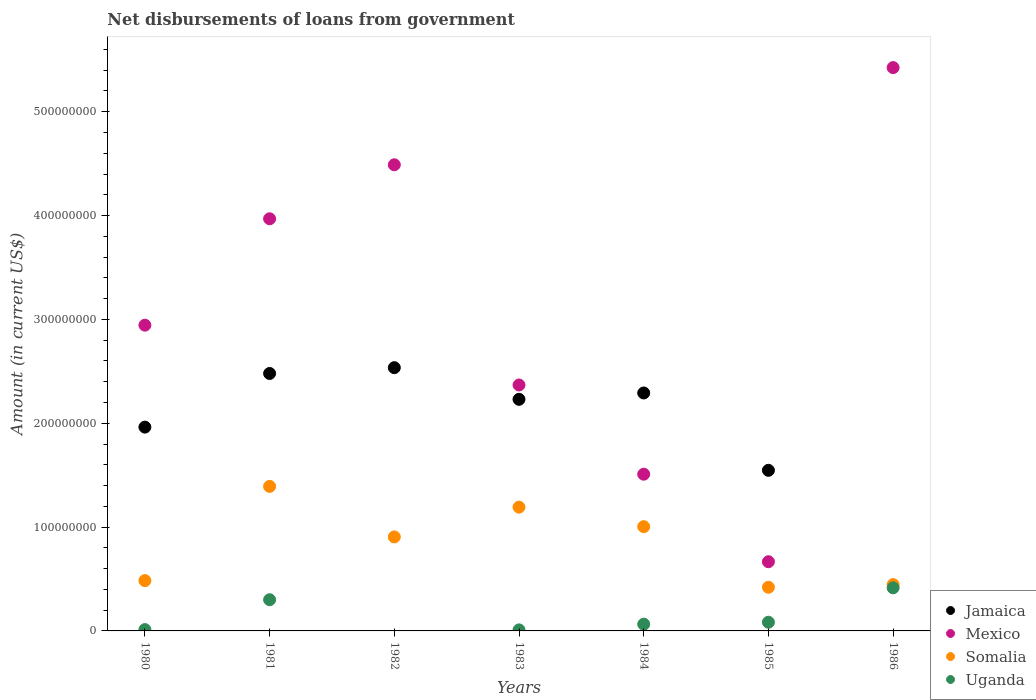Is the number of dotlines equal to the number of legend labels?
Give a very brief answer. No. What is the amount of loan disbursed from government in Somalia in 1983?
Give a very brief answer. 1.19e+08. Across all years, what is the maximum amount of loan disbursed from government in Somalia?
Make the answer very short. 1.39e+08. Across all years, what is the minimum amount of loan disbursed from government in Uganda?
Offer a terse response. 0. In which year was the amount of loan disbursed from government in Somalia maximum?
Ensure brevity in your answer.  1981. What is the total amount of loan disbursed from government in Jamaica in the graph?
Offer a terse response. 1.30e+09. What is the difference between the amount of loan disbursed from government in Somalia in 1981 and that in 1984?
Keep it short and to the point. 3.88e+07. What is the difference between the amount of loan disbursed from government in Uganda in 1986 and the amount of loan disbursed from government in Somalia in 1980?
Your response must be concise. -6.95e+06. What is the average amount of loan disbursed from government in Somalia per year?
Make the answer very short. 8.35e+07. In the year 1986, what is the difference between the amount of loan disbursed from government in Mexico and amount of loan disbursed from government in Uganda?
Provide a short and direct response. 5.01e+08. What is the ratio of the amount of loan disbursed from government in Mexico in 1982 to that in 1983?
Offer a very short reply. 1.9. Is the difference between the amount of loan disbursed from government in Mexico in 1980 and 1985 greater than the difference between the amount of loan disbursed from government in Uganda in 1980 and 1985?
Offer a very short reply. Yes. What is the difference between the highest and the second highest amount of loan disbursed from government in Uganda?
Provide a short and direct response. 1.15e+07. What is the difference between the highest and the lowest amount of loan disbursed from government in Mexico?
Your answer should be compact. 4.76e+08. Is the sum of the amount of loan disbursed from government in Mexico in 1983 and 1986 greater than the maximum amount of loan disbursed from government in Somalia across all years?
Your answer should be very brief. Yes. Is it the case that in every year, the sum of the amount of loan disbursed from government in Mexico and amount of loan disbursed from government in Somalia  is greater than the sum of amount of loan disbursed from government in Jamaica and amount of loan disbursed from government in Uganda?
Your answer should be compact. Yes. Is the amount of loan disbursed from government in Mexico strictly greater than the amount of loan disbursed from government in Uganda over the years?
Your answer should be compact. Yes. How many years are there in the graph?
Make the answer very short. 7. How many legend labels are there?
Give a very brief answer. 4. What is the title of the graph?
Provide a short and direct response. Net disbursements of loans from government. What is the label or title of the X-axis?
Give a very brief answer. Years. What is the label or title of the Y-axis?
Your response must be concise. Amount (in current US$). What is the Amount (in current US$) of Jamaica in 1980?
Keep it short and to the point. 1.96e+08. What is the Amount (in current US$) of Mexico in 1980?
Keep it short and to the point. 2.94e+08. What is the Amount (in current US$) of Somalia in 1980?
Give a very brief answer. 4.85e+07. What is the Amount (in current US$) of Uganda in 1980?
Provide a short and direct response. 1.26e+06. What is the Amount (in current US$) of Jamaica in 1981?
Your response must be concise. 2.48e+08. What is the Amount (in current US$) in Mexico in 1981?
Your answer should be compact. 3.97e+08. What is the Amount (in current US$) of Somalia in 1981?
Give a very brief answer. 1.39e+08. What is the Amount (in current US$) in Uganda in 1981?
Provide a short and direct response. 3.00e+07. What is the Amount (in current US$) in Jamaica in 1982?
Provide a succinct answer. 2.54e+08. What is the Amount (in current US$) in Mexico in 1982?
Provide a short and direct response. 4.49e+08. What is the Amount (in current US$) of Somalia in 1982?
Your answer should be compact. 9.05e+07. What is the Amount (in current US$) of Uganda in 1982?
Your response must be concise. 0. What is the Amount (in current US$) in Jamaica in 1983?
Your answer should be compact. 2.23e+08. What is the Amount (in current US$) of Mexico in 1983?
Your response must be concise. 2.37e+08. What is the Amount (in current US$) of Somalia in 1983?
Offer a very short reply. 1.19e+08. What is the Amount (in current US$) in Uganda in 1983?
Your answer should be very brief. 9.88e+05. What is the Amount (in current US$) in Jamaica in 1984?
Ensure brevity in your answer.  2.29e+08. What is the Amount (in current US$) of Mexico in 1984?
Make the answer very short. 1.51e+08. What is the Amount (in current US$) in Somalia in 1984?
Your answer should be very brief. 1.00e+08. What is the Amount (in current US$) of Uganda in 1984?
Ensure brevity in your answer.  6.49e+06. What is the Amount (in current US$) of Jamaica in 1985?
Provide a short and direct response. 1.55e+08. What is the Amount (in current US$) of Mexico in 1985?
Your answer should be compact. 6.66e+07. What is the Amount (in current US$) in Somalia in 1985?
Keep it short and to the point. 4.20e+07. What is the Amount (in current US$) in Uganda in 1985?
Keep it short and to the point. 8.37e+06. What is the Amount (in current US$) of Jamaica in 1986?
Offer a terse response. 0. What is the Amount (in current US$) in Mexico in 1986?
Offer a very short reply. 5.42e+08. What is the Amount (in current US$) of Somalia in 1986?
Your answer should be very brief. 4.46e+07. What is the Amount (in current US$) in Uganda in 1986?
Ensure brevity in your answer.  4.15e+07. Across all years, what is the maximum Amount (in current US$) in Jamaica?
Ensure brevity in your answer.  2.54e+08. Across all years, what is the maximum Amount (in current US$) of Mexico?
Your answer should be very brief. 5.42e+08. Across all years, what is the maximum Amount (in current US$) of Somalia?
Ensure brevity in your answer.  1.39e+08. Across all years, what is the maximum Amount (in current US$) in Uganda?
Offer a very short reply. 4.15e+07. Across all years, what is the minimum Amount (in current US$) in Jamaica?
Keep it short and to the point. 0. Across all years, what is the minimum Amount (in current US$) of Mexico?
Ensure brevity in your answer.  6.66e+07. Across all years, what is the minimum Amount (in current US$) of Somalia?
Offer a very short reply. 4.20e+07. What is the total Amount (in current US$) in Jamaica in the graph?
Give a very brief answer. 1.30e+09. What is the total Amount (in current US$) of Mexico in the graph?
Keep it short and to the point. 2.14e+09. What is the total Amount (in current US$) in Somalia in the graph?
Your answer should be very brief. 5.84e+08. What is the total Amount (in current US$) of Uganda in the graph?
Your answer should be compact. 8.87e+07. What is the difference between the Amount (in current US$) of Jamaica in 1980 and that in 1981?
Give a very brief answer. -5.17e+07. What is the difference between the Amount (in current US$) of Mexico in 1980 and that in 1981?
Provide a short and direct response. -1.02e+08. What is the difference between the Amount (in current US$) in Somalia in 1980 and that in 1981?
Offer a very short reply. -9.07e+07. What is the difference between the Amount (in current US$) of Uganda in 1980 and that in 1981?
Give a very brief answer. -2.88e+07. What is the difference between the Amount (in current US$) of Jamaica in 1980 and that in 1982?
Your response must be concise. -5.73e+07. What is the difference between the Amount (in current US$) of Mexico in 1980 and that in 1982?
Keep it short and to the point. -1.54e+08. What is the difference between the Amount (in current US$) of Somalia in 1980 and that in 1982?
Your response must be concise. -4.21e+07. What is the difference between the Amount (in current US$) in Jamaica in 1980 and that in 1983?
Make the answer very short. -2.68e+07. What is the difference between the Amount (in current US$) of Mexico in 1980 and that in 1983?
Provide a succinct answer. 5.76e+07. What is the difference between the Amount (in current US$) of Somalia in 1980 and that in 1983?
Keep it short and to the point. -7.07e+07. What is the difference between the Amount (in current US$) of Uganda in 1980 and that in 1983?
Your answer should be compact. 2.77e+05. What is the difference between the Amount (in current US$) of Jamaica in 1980 and that in 1984?
Provide a short and direct response. -3.29e+07. What is the difference between the Amount (in current US$) in Mexico in 1980 and that in 1984?
Your answer should be compact. 1.44e+08. What is the difference between the Amount (in current US$) of Somalia in 1980 and that in 1984?
Ensure brevity in your answer.  -5.19e+07. What is the difference between the Amount (in current US$) of Uganda in 1980 and that in 1984?
Your answer should be compact. -5.23e+06. What is the difference between the Amount (in current US$) in Jamaica in 1980 and that in 1985?
Provide a short and direct response. 4.16e+07. What is the difference between the Amount (in current US$) in Mexico in 1980 and that in 1985?
Provide a succinct answer. 2.28e+08. What is the difference between the Amount (in current US$) of Somalia in 1980 and that in 1985?
Offer a very short reply. 6.42e+06. What is the difference between the Amount (in current US$) in Uganda in 1980 and that in 1985?
Provide a succinct answer. -7.10e+06. What is the difference between the Amount (in current US$) of Mexico in 1980 and that in 1986?
Ensure brevity in your answer.  -2.48e+08. What is the difference between the Amount (in current US$) in Somalia in 1980 and that in 1986?
Offer a terse response. 3.84e+06. What is the difference between the Amount (in current US$) in Uganda in 1980 and that in 1986?
Make the answer very short. -4.02e+07. What is the difference between the Amount (in current US$) of Jamaica in 1981 and that in 1982?
Provide a succinct answer. -5.60e+06. What is the difference between the Amount (in current US$) in Mexico in 1981 and that in 1982?
Offer a terse response. -5.20e+07. What is the difference between the Amount (in current US$) of Somalia in 1981 and that in 1982?
Your answer should be compact. 4.87e+07. What is the difference between the Amount (in current US$) of Jamaica in 1981 and that in 1983?
Offer a very short reply. 2.49e+07. What is the difference between the Amount (in current US$) in Mexico in 1981 and that in 1983?
Make the answer very short. 1.60e+08. What is the difference between the Amount (in current US$) of Somalia in 1981 and that in 1983?
Give a very brief answer. 2.00e+07. What is the difference between the Amount (in current US$) of Uganda in 1981 and that in 1983?
Your answer should be compact. 2.91e+07. What is the difference between the Amount (in current US$) of Jamaica in 1981 and that in 1984?
Your answer should be compact. 1.88e+07. What is the difference between the Amount (in current US$) of Mexico in 1981 and that in 1984?
Offer a terse response. 2.46e+08. What is the difference between the Amount (in current US$) in Somalia in 1981 and that in 1984?
Offer a very short reply. 3.88e+07. What is the difference between the Amount (in current US$) in Uganda in 1981 and that in 1984?
Keep it short and to the point. 2.35e+07. What is the difference between the Amount (in current US$) of Jamaica in 1981 and that in 1985?
Give a very brief answer. 9.33e+07. What is the difference between the Amount (in current US$) of Mexico in 1981 and that in 1985?
Offer a very short reply. 3.30e+08. What is the difference between the Amount (in current US$) in Somalia in 1981 and that in 1985?
Offer a very short reply. 9.72e+07. What is the difference between the Amount (in current US$) of Uganda in 1981 and that in 1985?
Keep it short and to the point. 2.17e+07. What is the difference between the Amount (in current US$) in Mexico in 1981 and that in 1986?
Provide a succinct answer. -1.46e+08. What is the difference between the Amount (in current US$) of Somalia in 1981 and that in 1986?
Your response must be concise. 9.46e+07. What is the difference between the Amount (in current US$) of Uganda in 1981 and that in 1986?
Provide a short and direct response. -1.15e+07. What is the difference between the Amount (in current US$) in Jamaica in 1982 and that in 1983?
Your response must be concise. 3.05e+07. What is the difference between the Amount (in current US$) in Mexico in 1982 and that in 1983?
Your answer should be compact. 2.12e+08. What is the difference between the Amount (in current US$) of Somalia in 1982 and that in 1983?
Provide a succinct answer. -2.87e+07. What is the difference between the Amount (in current US$) in Jamaica in 1982 and that in 1984?
Your answer should be compact. 2.44e+07. What is the difference between the Amount (in current US$) in Mexico in 1982 and that in 1984?
Your answer should be very brief. 2.98e+08. What is the difference between the Amount (in current US$) of Somalia in 1982 and that in 1984?
Ensure brevity in your answer.  -9.89e+06. What is the difference between the Amount (in current US$) of Jamaica in 1982 and that in 1985?
Provide a succinct answer. 9.88e+07. What is the difference between the Amount (in current US$) of Mexico in 1982 and that in 1985?
Your answer should be very brief. 3.82e+08. What is the difference between the Amount (in current US$) in Somalia in 1982 and that in 1985?
Give a very brief answer. 4.85e+07. What is the difference between the Amount (in current US$) of Mexico in 1982 and that in 1986?
Offer a very short reply. -9.36e+07. What is the difference between the Amount (in current US$) of Somalia in 1982 and that in 1986?
Offer a very short reply. 4.59e+07. What is the difference between the Amount (in current US$) of Jamaica in 1983 and that in 1984?
Provide a short and direct response. -6.11e+06. What is the difference between the Amount (in current US$) in Mexico in 1983 and that in 1984?
Your response must be concise. 8.59e+07. What is the difference between the Amount (in current US$) of Somalia in 1983 and that in 1984?
Make the answer very short. 1.88e+07. What is the difference between the Amount (in current US$) in Uganda in 1983 and that in 1984?
Make the answer very short. -5.50e+06. What is the difference between the Amount (in current US$) in Jamaica in 1983 and that in 1985?
Your response must be concise. 6.84e+07. What is the difference between the Amount (in current US$) of Mexico in 1983 and that in 1985?
Make the answer very short. 1.70e+08. What is the difference between the Amount (in current US$) of Somalia in 1983 and that in 1985?
Offer a terse response. 7.72e+07. What is the difference between the Amount (in current US$) in Uganda in 1983 and that in 1985?
Your answer should be compact. -7.38e+06. What is the difference between the Amount (in current US$) of Mexico in 1983 and that in 1986?
Your response must be concise. -3.06e+08. What is the difference between the Amount (in current US$) in Somalia in 1983 and that in 1986?
Your answer should be very brief. 7.46e+07. What is the difference between the Amount (in current US$) in Uganda in 1983 and that in 1986?
Your answer should be compact. -4.05e+07. What is the difference between the Amount (in current US$) in Jamaica in 1984 and that in 1985?
Your response must be concise. 7.45e+07. What is the difference between the Amount (in current US$) in Mexico in 1984 and that in 1985?
Provide a succinct answer. 8.43e+07. What is the difference between the Amount (in current US$) in Somalia in 1984 and that in 1985?
Keep it short and to the point. 5.84e+07. What is the difference between the Amount (in current US$) of Uganda in 1984 and that in 1985?
Provide a succinct answer. -1.88e+06. What is the difference between the Amount (in current US$) of Mexico in 1984 and that in 1986?
Offer a very short reply. -3.92e+08. What is the difference between the Amount (in current US$) in Somalia in 1984 and that in 1986?
Make the answer very short. 5.58e+07. What is the difference between the Amount (in current US$) of Uganda in 1984 and that in 1986?
Your answer should be compact. -3.50e+07. What is the difference between the Amount (in current US$) in Mexico in 1985 and that in 1986?
Your answer should be very brief. -4.76e+08. What is the difference between the Amount (in current US$) in Somalia in 1985 and that in 1986?
Provide a succinct answer. -2.58e+06. What is the difference between the Amount (in current US$) in Uganda in 1985 and that in 1986?
Offer a very short reply. -3.31e+07. What is the difference between the Amount (in current US$) in Jamaica in 1980 and the Amount (in current US$) in Mexico in 1981?
Your response must be concise. -2.01e+08. What is the difference between the Amount (in current US$) of Jamaica in 1980 and the Amount (in current US$) of Somalia in 1981?
Your answer should be compact. 5.71e+07. What is the difference between the Amount (in current US$) of Jamaica in 1980 and the Amount (in current US$) of Uganda in 1981?
Keep it short and to the point. 1.66e+08. What is the difference between the Amount (in current US$) in Mexico in 1980 and the Amount (in current US$) in Somalia in 1981?
Offer a very short reply. 1.55e+08. What is the difference between the Amount (in current US$) in Mexico in 1980 and the Amount (in current US$) in Uganda in 1981?
Offer a very short reply. 2.64e+08. What is the difference between the Amount (in current US$) in Somalia in 1980 and the Amount (in current US$) in Uganda in 1981?
Your answer should be very brief. 1.84e+07. What is the difference between the Amount (in current US$) of Jamaica in 1980 and the Amount (in current US$) of Mexico in 1982?
Keep it short and to the point. -2.53e+08. What is the difference between the Amount (in current US$) in Jamaica in 1980 and the Amount (in current US$) in Somalia in 1982?
Make the answer very short. 1.06e+08. What is the difference between the Amount (in current US$) of Mexico in 1980 and the Amount (in current US$) of Somalia in 1982?
Offer a very short reply. 2.04e+08. What is the difference between the Amount (in current US$) of Jamaica in 1980 and the Amount (in current US$) of Mexico in 1983?
Offer a terse response. -4.06e+07. What is the difference between the Amount (in current US$) in Jamaica in 1980 and the Amount (in current US$) in Somalia in 1983?
Provide a succinct answer. 7.71e+07. What is the difference between the Amount (in current US$) of Jamaica in 1980 and the Amount (in current US$) of Uganda in 1983?
Your answer should be very brief. 1.95e+08. What is the difference between the Amount (in current US$) in Mexico in 1980 and the Amount (in current US$) in Somalia in 1983?
Your answer should be compact. 1.75e+08. What is the difference between the Amount (in current US$) of Mexico in 1980 and the Amount (in current US$) of Uganda in 1983?
Ensure brevity in your answer.  2.93e+08. What is the difference between the Amount (in current US$) of Somalia in 1980 and the Amount (in current US$) of Uganda in 1983?
Your response must be concise. 4.75e+07. What is the difference between the Amount (in current US$) of Jamaica in 1980 and the Amount (in current US$) of Mexico in 1984?
Provide a succinct answer. 4.53e+07. What is the difference between the Amount (in current US$) of Jamaica in 1980 and the Amount (in current US$) of Somalia in 1984?
Your response must be concise. 9.59e+07. What is the difference between the Amount (in current US$) in Jamaica in 1980 and the Amount (in current US$) in Uganda in 1984?
Offer a terse response. 1.90e+08. What is the difference between the Amount (in current US$) in Mexico in 1980 and the Amount (in current US$) in Somalia in 1984?
Provide a short and direct response. 1.94e+08. What is the difference between the Amount (in current US$) in Mexico in 1980 and the Amount (in current US$) in Uganda in 1984?
Offer a terse response. 2.88e+08. What is the difference between the Amount (in current US$) in Somalia in 1980 and the Amount (in current US$) in Uganda in 1984?
Your response must be concise. 4.20e+07. What is the difference between the Amount (in current US$) of Jamaica in 1980 and the Amount (in current US$) of Mexico in 1985?
Your answer should be very brief. 1.30e+08. What is the difference between the Amount (in current US$) of Jamaica in 1980 and the Amount (in current US$) of Somalia in 1985?
Your answer should be very brief. 1.54e+08. What is the difference between the Amount (in current US$) of Jamaica in 1980 and the Amount (in current US$) of Uganda in 1985?
Your answer should be compact. 1.88e+08. What is the difference between the Amount (in current US$) of Mexico in 1980 and the Amount (in current US$) of Somalia in 1985?
Give a very brief answer. 2.52e+08. What is the difference between the Amount (in current US$) of Mexico in 1980 and the Amount (in current US$) of Uganda in 1985?
Give a very brief answer. 2.86e+08. What is the difference between the Amount (in current US$) in Somalia in 1980 and the Amount (in current US$) in Uganda in 1985?
Provide a succinct answer. 4.01e+07. What is the difference between the Amount (in current US$) in Jamaica in 1980 and the Amount (in current US$) in Mexico in 1986?
Give a very brief answer. -3.46e+08. What is the difference between the Amount (in current US$) of Jamaica in 1980 and the Amount (in current US$) of Somalia in 1986?
Make the answer very short. 1.52e+08. What is the difference between the Amount (in current US$) in Jamaica in 1980 and the Amount (in current US$) in Uganda in 1986?
Give a very brief answer. 1.55e+08. What is the difference between the Amount (in current US$) in Mexico in 1980 and the Amount (in current US$) in Somalia in 1986?
Your answer should be very brief. 2.50e+08. What is the difference between the Amount (in current US$) of Mexico in 1980 and the Amount (in current US$) of Uganda in 1986?
Provide a succinct answer. 2.53e+08. What is the difference between the Amount (in current US$) in Somalia in 1980 and the Amount (in current US$) in Uganda in 1986?
Make the answer very short. 6.95e+06. What is the difference between the Amount (in current US$) of Jamaica in 1981 and the Amount (in current US$) of Mexico in 1982?
Your response must be concise. -2.01e+08. What is the difference between the Amount (in current US$) in Jamaica in 1981 and the Amount (in current US$) in Somalia in 1982?
Your response must be concise. 1.57e+08. What is the difference between the Amount (in current US$) of Mexico in 1981 and the Amount (in current US$) of Somalia in 1982?
Your answer should be compact. 3.06e+08. What is the difference between the Amount (in current US$) in Jamaica in 1981 and the Amount (in current US$) in Mexico in 1983?
Offer a very short reply. 1.11e+07. What is the difference between the Amount (in current US$) of Jamaica in 1981 and the Amount (in current US$) of Somalia in 1983?
Your answer should be very brief. 1.29e+08. What is the difference between the Amount (in current US$) of Jamaica in 1981 and the Amount (in current US$) of Uganda in 1983?
Keep it short and to the point. 2.47e+08. What is the difference between the Amount (in current US$) in Mexico in 1981 and the Amount (in current US$) in Somalia in 1983?
Make the answer very short. 2.78e+08. What is the difference between the Amount (in current US$) of Mexico in 1981 and the Amount (in current US$) of Uganda in 1983?
Provide a short and direct response. 3.96e+08. What is the difference between the Amount (in current US$) in Somalia in 1981 and the Amount (in current US$) in Uganda in 1983?
Provide a short and direct response. 1.38e+08. What is the difference between the Amount (in current US$) of Jamaica in 1981 and the Amount (in current US$) of Mexico in 1984?
Provide a short and direct response. 9.70e+07. What is the difference between the Amount (in current US$) of Jamaica in 1981 and the Amount (in current US$) of Somalia in 1984?
Offer a terse response. 1.48e+08. What is the difference between the Amount (in current US$) in Jamaica in 1981 and the Amount (in current US$) in Uganda in 1984?
Make the answer very short. 2.41e+08. What is the difference between the Amount (in current US$) in Mexico in 1981 and the Amount (in current US$) in Somalia in 1984?
Your response must be concise. 2.96e+08. What is the difference between the Amount (in current US$) of Mexico in 1981 and the Amount (in current US$) of Uganda in 1984?
Make the answer very short. 3.90e+08. What is the difference between the Amount (in current US$) of Somalia in 1981 and the Amount (in current US$) of Uganda in 1984?
Offer a very short reply. 1.33e+08. What is the difference between the Amount (in current US$) of Jamaica in 1981 and the Amount (in current US$) of Mexico in 1985?
Your answer should be compact. 1.81e+08. What is the difference between the Amount (in current US$) in Jamaica in 1981 and the Amount (in current US$) in Somalia in 1985?
Your answer should be compact. 2.06e+08. What is the difference between the Amount (in current US$) of Jamaica in 1981 and the Amount (in current US$) of Uganda in 1985?
Your response must be concise. 2.40e+08. What is the difference between the Amount (in current US$) of Mexico in 1981 and the Amount (in current US$) of Somalia in 1985?
Your response must be concise. 3.55e+08. What is the difference between the Amount (in current US$) of Mexico in 1981 and the Amount (in current US$) of Uganda in 1985?
Your answer should be very brief. 3.89e+08. What is the difference between the Amount (in current US$) in Somalia in 1981 and the Amount (in current US$) in Uganda in 1985?
Make the answer very short. 1.31e+08. What is the difference between the Amount (in current US$) in Jamaica in 1981 and the Amount (in current US$) in Mexico in 1986?
Your answer should be compact. -2.95e+08. What is the difference between the Amount (in current US$) in Jamaica in 1981 and the Amount (in current US$) in Somalia in 1986?
Provide a short and direct response. 2.03e+08. What is the difference between the Amount (in current US$) of Jamaica in 1981 and the Amount (in current US$) of Uganda in 1986?
Make the answer very short. 2.06e+08. What is the difference between the Amount (in current US$) of Mexico in 1981 and the Amount (in current US$) of Somalia in 1986?
Your answer should be very brief. 3.52e+08. What is the difference between the Amount (in current US$) in Mexico in 1981 and the Amount (in current US$) in Uganda in 1986?
Offer a very short reply. 3.55e+08. What is the difference between the Amount (in current US$) in Somalia in 1981 and the Amount (in current US$) in Uganda in 1986?
Your answer should be compact. 9.77e+07. What is the difference between the Amount (in current US$) in Jamaica in 1982 and the Amount (in current US$) in Mexico in 1983?
Give a very brief answer. 1.67e+07. What is the difference between the Amount (in current US$) of Jamaica in 1982 and the Amount (in current US$) of Somalia in 1983?
Provide a short and direct response. 1.34e+08. What is the difference between the Amount (in current US$) of Jamaica in 1982 and the Amount (in current US$) of Uganda in 1983?
Provide a succinct answer. 2.53e+08. What is the difference between the Amount (in current US$) in Mexico in 1982 and the Amount (in current US$) in Somalia in 1983?
Offer a very short reply. 3.30e+08. What is the difference between the Amount (in current US$) of Mexico in 1982 and the Amount (in current US$) of Uganda in 1983?
Provide a short and direct response. 4.48e+08. What is the difference between the Amount (in current US$) in Somalia in 1982 and the Amount (in current US$) in Uganda in 1983?
Offer a very short reply. 8.95e+07. What is the difference between the Amount (in current US$) of Jamaica in 1982 and the Amount (in current US$) of Mexico in 1984?
Provide a short and direct response. 1.03e+08. What is the difference between the Amount (in current US$) of Jamaica in 1982 and the Amount (in current US$) of Somalia in 1984?
Give a very brief answer. 1.53e+08. What is the difference between the Amount (in current US$) in Jamaica in 1982 and the Amount (in current US$) in Uganda in 1984?
Provide a short and direct response. 2.47e+08. What is the difference between the Amount (in current US$) in Mexico in 1982 and the Amount (in current US$) in Somalia in 1984?
Ensure brevity in your answer.  3.49e+08. What is the difference between the Amount (in current US$) in Mexico in 1982 and the Amount (in current US$) in Uganda in 1984?
Make the answer very short. 4.42e+08. What is the difference between the Amount (in current US$) in Somalia in 1982 and the Amount (in current US$) in Uganda in 1984?
Your answer should be very brief. 8.40e+07. What is the difference between the Amount (in current US$) of Jamaica in 1982 and the Amount (in current US$) of Mexico in 1985?
Ensure brevity in your answer.  1.87e+08. What is the difference between the Amount (in current US$) of Jamaica in 1982 and the Amount (in current US$) of Somalia in 1985?
Your answer should be very brief. 2.11e+08. What is the difference between the Amount (in current US$) in Jamaica in 1982 and the Amount (in current US$) in Uganda in 1985?
Offer a terse response. 2.45e+08. What is the difference between the Amount (in current US$) in Mexico in 1982 and the Amount (in current US$) in Somalia in 1985?
Ensure brevity in your answer.  4.07e+08. What is the difference between the Amount (in current US$) in Mexico in 1982 and the Amount (in current US$) in Uganda in 1985?
Your answer should be very brief. 4.41e+08. What is the difference between the Amount (in current US$) of Somalia in 1982 and the Amount (in current US$) of Uganda in 1985?
Provide a succinct answer. 8.21e+07. What is the difference between the Amount (in current US$) of Jamaica in 1982 and the Amount (in current US$) of Mexico in 1986?
Make the answer very short. -2.89e+08. What is the difference between the Amount (in current US$) in Jamaica in 1982 and the Amount (in current US$) in Somalia in 1986?
Offer a very short reply. 2.09e+08. What is the difference between the Amount (in current US$) of Jamaica in 1982 and the Amount (in current US$) of Uganda in 1986?
Give a very brief answer. 2.12e+08. What is the difference between the Amount (in current US$) of Mexico in 1982 and the Amount (in current US$) of Somalia in 1986?
Provide a short and direct response. 4.04e+08. What is the difference between the Amount (in current US$) of Mexico in 1982 and the Amount (in current US$) of Uganda in 1986?
Ensure brevity in your answer.  4.07e+08. What is the difference between the Amount (in current US$) in Somalia in 1982 and the Amount (in current US$) in Uganda in 1986?
Your answer should be very brief. 4.90e+07. What is the difference between the Amount (in current US$) of Jamaica in 1983 and the Amount (in current US$) of Mexico in 1984?
Your response must be concise. 7.21e+07. What is the difference between the Amount (in current US$) of Jamaica in 1983 and the Amount (in current US$) of Somalia in 1984?
Offer a terse response. 1.23e+08. What is the difference between the Amount (in current US$) in Jamaica in 1983 and the Amount (in current US$) in Uganda in 1984?
Keep it short and to the point. 2.17e+08. What is the difference between the Amount (in current US$) of Mexico in 1983 and the Amount (in current US$) of Somalia in 1984?
Provide a succinct answer. 1.36e+08. What is the difference between the Amount (in current US$) in Mexico in 1983 and the Amount (in current US$) in Uganda in 1984?
Offer a terse response. 2.30e+08. What is the difference between the Amount (in current US$) of Somalia in 1983 and the Amount (in current US$) of Uganda in 1984?
Ensure brevity in your answer.  1.13e+08. What is the difference between the Amount (in current US$) in Jamaica in 1983 and the Amount (in current US$) in Mexico in 1985?
Offer a very short reply. 1.56e+08. What is the difference between the Amount (in current US$) of Jamaica in 1983 and the Amount (in current US$) of Somalia in 1985?
Give a very brief answer. 1.81e+08. What is the difference between the Amount (in current US$) in Jamaica in 1983 and the Amount (in current US$) in Uganda in 1985?
Ensure brevity in your answer.  2.15e+08. What is the difference between the Amount (in current US$) in Mexico in 1983 and the Amount (in current US$) in Somalia in 1985?
Provide a short and direct response. 1.95e+08. What is the difference between the Amount (in current US$) of Mexico in 1983 and the Amount (in current US$) of Uganda in 1985?
Keep it short and to the point. 2.28e+08. What is the difference between the Amount (in current US$) of Somalia in 1983 and the Amount (in current US$) of Uganda in 1985?
Keep it short and to the point. 1.11e+08. What is the difference between the Amount (in current US$) of Jamaica in 1983 and the Amount (in current US$) of Mexico in 1986?
Ensure brevity in your answer.  -3.19e+08. What is the difference between the Amount (in current US$) of Jamaica in 1983 and the Amount (in current US$) of Somalia in 1986?
Provide a succinct answer. 1.78e+08. What is the difference between the Amount (in current US$) in Jamaica in 1983 and the Amount (in current US$) in Uganda in 1986?
Provide a succinct answer. 1.82e+08. What is the difference between the Amount (in current US$) in Mexico in 1983 and the Amount (in current US$) in Somalia in 1986?
Provide a succinct answer. 1.92e+08. What is the difference between the Amount (in current US$) of Mexico in 1983 and the Amount (in current US$) of Uganda in 1986?
Provide a succinct answer. 1.95e+08. What is the difference between the Amount (in current US$) of Somalia in 1983 and the Amount (in current US$) of Uganda in 1986?
Your response must be concise. 7.77e+07. What is the difference between the Amount (in current US$) in Jamaica in 1984 and the Amount (in current US$) in Mexico in 1985?
Provide a succinct answer. 1.63e+08. What is the difference between the Amount (in current US$) in Jamaica in 1984 and the Amount (in current US$) in Somalia in 1985?
Your answer should be very brief. 1.87e+08. What is the difference between the Amount (in current US$) in Jamaica in 1984 and the Amount (in current US$) in Uganda in 1985?
Offer a terse response. 2.21e+08. What is the difference between the Amount (in current US$) of Mexico in 1984 and the Amount (in current US$) of Somalia in 1985?
Provide a short and direct response. 1.09e+08. What is the difference between the Amount (in current US$) of Mexico in 1984 and the Amount (in current US$) of Uganda in 1985?
Make the answer very short. 1.43e+08. What is the difference between the Amount (in current US$) of Somalia in 1984 and the Amount (in current US$) of Uganda in 1985?
Your answer should be compact. 9.20e+07. What is the difference between the Amount (in current US$) in Jamaica in 1984 and the Amount (in current US$) in Mexico in 1986?
Your answer should be very brief. -3.13e+08. What is the difference between the Amount (in current US$) of Jamaica in 1984 and the Amount (in current US$) of Somalia in 1986?
Your answer should be compact. 1.85e+08. What is the difference between the Amount (in current US$) of Jamaica in 1984 and the Amount (in current US$) of Uganda in 1986?
Your answer should be compact. 1.88e+08. What is the difference between the Amount (in current US$) of Mexico in 1984 and the Amount (in current US$) of Somalia in 1986?
Provide a succinct answer. 1.06e+08. What is the difference between the Amount (in current US$) of Mexico in 1984 and the Amount (in current US$) of Uganda in 1986?
Your answer should be compact. 1.09e+08. What is the difference between the Amount (in current US$) of Somalia in 1984 and the Amount (in current US$) of Uganda in 1986?
Offer a very short reply. 5.89e+07. What is the difference between the Amount (in current US$) of Jamaica in 1985 and the Amount (in current US$) of Mexico in 1986?
Make the answer very short. -3.88e+08. What is the difference between the Amount (in current US$) of Jamaica in 1985 and the Amount (in current US$) of Somalia in 1986?
Provide a succinct answer. 1.10e+08. What is the difference between the Amount (in current US$) in Jamaica in 1985 and the Amount (in current US$) in Uganda in 1986?
Offer a very short reply. 1.13e+08. What is the difference between the Amount (in current US$) in Mexico in 1985 and the Amount (in current US$) in Somalia in 1986?
Your answer should be very brief. 2.20e+07. What is the difference between the Amount (in current US$) in Mexico in 1985 and the Amount (in current US$) in Uganda in 1986?
Offer a terse response. 2.51e+07. What is the difference between the Amount (in current US$) of Somalia in 1985 and the Amount (in current US$) of Uganda in 1986?
Offer a very short reply. 5.30e+05. What is the average Amount (in current US$) in Jamaica per year?
Your answer should be compact. 1.86e+08. What is the average Amount (in current US$) of Mexico per year?
Offer a terse response. 3.05e+08. What is the average Amount (in current US$) of Somalia per year?
Offer a terse response. 8.35e+07. What is the average Amount (in current US$) of Uganda per year?
Provide a short and direct response. 1.27e+07. In the year 1980, what is the difference between the Amount (in current US$) in Jamaica and Amount (in current US$) in Mexico?
Your answer should be compact. -9.82e+07. In the year 1980, what is the difference between the Amount (in current US$) of Jamaica and Amount (in current US$) of Somalia?
Offer a very short reply. 1.48e+08. In the year 1980, what is the difference between the Amount (in current US$) in Jamaica and Amount (in current US$) in Uganda?
Ensure brevity in your answer.  1.95e+08. In the year 1980, what is the difference between the Amount (in current US$) in Mexico and Amount (in current US$) in Somalia?
Provide a succinct answer. 2.46e+08. In the year 1980, what is the difference between the Amount (in current US$) of Mexico and Amount (in current US$) of Uganda?
Provide a succinct answer. 2.93e+08. In the year 1980, what is the difference between the Amount (in current US$) of Somalia and Amount (in current US$) of Uganda?
Keep it short and to the point. 4.72e+07. In the year 1981, what is the difference between the Amount (in current US$) of Jamaica and Amount (in current US$) of Mexico?
Provide a succinct answer. -1.49e+08. In the year 1981, what is the difference between the Amount (in current US$) in Jamaica and Amount (in current US$) in Somalia?
Ensure brevity in your answer.  1.09e+08. In the year 1981, what is the difference between the Amount (in current US$) of Jamaica and Amount (in current US$) of Uganda?
Offer a very short reply. 2.18e+08. In the year 1981, what is the difference between the Amount (in current US$) in Mexico and Amount (in current US$) in Somalia?
Keep it short and to the point. 2.58e+08. In the year 1981, what is the difference between the Amount (in current US$) of Mexico and Amount (in current US$) of Uganda?
Provide a short and direct response. 3.67e+08. In the year 1981, what is the difference between the Amount (in current US$) of Somalia and Amount (in current US$) of Uganda?
Keep it short and to the point. 1.09e+08. In the year 1982, what is the difference between the Amount (in current US$) in Jamaica and Amount (in current US$) in Mexico?
Make the answer very short. -1.95e+08. In the year 1982, what is the difference between the Amount (in current US$) of Jamaica and Amount (in current US$) of Somalia?
Offer a terse response. 1.63e+08. In the year 1982, what is the difference between the Amount (in current US$) in Mexico and Amount (in current US$) in Somalia?
Your answer should be compact. 3.58e+08. In the year 1983, what is the difference between the Amount (in current US$) in Jamaica and Amount (in current US$) in Mexico?
Your answer should be very brief. -1.38e+07. In the year 1983, what is the difference between the Amount (in current US$) in Jamaica and Amount (in current US$) in Somalia?
Provide a short and direct response. 1.04e+08. In the year 1983, what is the difference between the Amount (in current US$) in Jamaica and Amount (in current US$) in Uganda?
Make the answer very short. 2.22e+08. In the year 1983, what is the difference between the Amount (in current US$) in Mexico and Amount (in current US$) in Somalia?
Offer a very short reply. 1.18e+08. In the year 1983, what is the difference between the Amount (in current US$) of Mexico and Amount (in current US$) of Uganda?
Offer a terse response. 2.36e+08. In the year 1983, what is the difference between the Amount (in current US$) in Somalia and Amount (in current US$) in Uganda?
Provide a short and direct response. 1.18e+08. In the year 1984, what is the difference between the Amount (in current US$) in Jamaica and Amount (in current US$) in Mexico?
Ensure brevity in your answer.  7.82e+07. In the year 1984, what is the difference between the Amount (in current US$) of Jamaica and Amount (in current US$) of Somalia?
Make the answer very short. 1.29e+08. In the year 1984, what is the difference between the Amount (in current US$) in Jamaica and Amount (in current US$) in Uganda?
Keep it short and to the point. 2.23e+08. In the year 1984, what is the difference between the Amount (in current US$) of Mexico and Amount (in current US$) of Somalia?
Your response must be concise. 5.05e+07. In the year 1984, what is the difference between the Amount (in current US$) of Mexico and Amount (in current US$) of Uganda?
Your response must be concise. 1.44e+08. In the year 1984, what is the difference between the Amount (in current US$) of Somalia and Amount (in current US$) of Uganda?
Ensure brevity in your answer.  9.39e+07. In the year 1985, what is the difference between the Amount (in current US$) of Jamaica and Amount (in current US$) of Mexico?
Your response must be concise. 8.80e+07. In the year 1985, what is the difference between the Amount (in current US$) of Jamaica and Amount (in current US$) of Somalia?
Provide a succinct answer. 1.13e+08. In the year 1985, what is the difference between the Amount (in current US$) of Jamaica and Amount (in current US$) of Uganda?
Ensure brevity in your answer.  1.46e+08. In the year 1985, what is the difference between the Amount (in current US$) in Mexico and Amount (in current US$) in Somalia?
Provide a succinct answer. 2.46e+07. In the year 1985, what is the difference between the Amount (in current US$) in Mexico and Amount (in current US$) in Uganda?
Give a very brief answer. 5.83e+07. In the year 1985, what is the difference between the Amount (in current US$) in Somalia and Amount (in current US$) in Uganda?
Give a very brief answer. 3.37e+07. In the year 1986, what is the difference between the Amount (in current US$) of Mexico and Amount (in current US$) of Somalia?
Provide a succinct answer. 4.98e+08. In the year 1986, what is the difference between the Amount (in current US$) in Mexico and Amount (in current US$) in Uganda?
Your answer should be compact. 5.01e+08. In the year 1986, what is the difference between the Amount (in current US$) of Somalia and Amount (in current US$) of Uganda?
Your answer should be compact. 3.11e+06. What is the ratio of the Amount (in current US$) in Jamaica in 1980 to that in 1981?
Offer a terse response. 0.79. What is the ratio of the Amount (in current US$) in Mexico in 1980 to that in 1981?
Keep it short and to the point. 0.74. What is the ratio of the Amount (in current US$) in Somalia in 1980 to that in 1981?
Provide a short and direct response. 0.35. What is the ratio of the Amount (in current US$) in Uganda in 1980 to that in 1981?
Your answer should be very brief. 0.04. What is the ratio of the Amount (in current US$) in Jamaica in 1980 to that in 1982?
Provide a short and direct response. 0.77. What is the ratio of the Amount (in current US$) in Mexico in 1980 to that in 1982?
Your answer should be very brief. 0.66. What is the ratio of the Amount (in current US$) of Somalia in 1980 to that in 1982?
Give a very brief answer. 0.54. What is the ratio of the Amount (in current US$) of Jamaica in 1980 to that in 1983?
Give a very brief answer. 0.88. What is the ratio of the Amount (in current US$) in Mexico in 1980 to that in 1983?
Offer a very short reply. 1.24. What is the ratio of the Amount (in current US$) in Somalia in 1980 to that in 1983?
Your answer should be very brief. 0.41. What is the ratio of the Amount (in current US$) of Uganda in 1980 to that in 1983?
Make the answer very short. 1.28. What is the ratio of the Amount (in current US$) in Jamaica in 1980 to that in 1984?
Provide a short and direct response. 0.86. What is the ratio of the Amount (in current US$) in Mexico in 1980 to that in 1984?
Your answer should be very brief. 1.95. What is the ratio of the Amount (in current US$) in Somalia in 1980 to that in 1984?
Make the answer very short. 0.48. What is the ratio of the Amount (in current US$) in Uganda in 1980 to that in 1984?
Make the answer very short. 0.19. What is the ratio of the Amount (in current US$) of Jamaica in 1980 to that in 1985?
Make the answer very short. 1.27. What is the ratio of the Amount (in current US$) in Mexico in 1980 to that in 1985?
Provide a short and direct response. 4.42. What is the ratio of the Amount (in current US$) of Somalia in 1980 to that in 1985?
Offer a terse response. 1.15. What is the ratio of the Amount (in current US$) of Uganda in 1980 to that in 1985?
Provide a short and direct response. 0.15. What is the ratio of the Amount (in current US$) in Mexico in 1980 to that in 1986?
Ensure brevity in your answer.  0.54. What is the ratio of the Amount (in current US$) of Somalia in 1980 to that in 1986?
Your answer should be compact. 1.09. What is the ratio of the Amount (in current US$) in Uganda in 1980 to that in 1986?
Provide a short and direct response. 0.03. What is the ratio of the Amount (in current US$) of Jamaica in 1981 to that in 1982?
Give a very brief answer. 0.98. What is the ratio of the Amount (in current US$) in Mexico in 1981 to that in 1982?
Your answer should be compact. 0.88. What is the ratio of the Amount (in current US$) of Somalia in 1981 to that in 1982?
Provide a short and direct response. 1.54. What is the ratio of the Amount (in current US$) of Jamaica in 1981 to that in 1983?
Provide a succinct answer. 1.11. What is the ratio of the Amount (in current US$) of Mexico in 1981 to that in 1983?
Your answer should be compact. 1.68. What is the ratio of the Amount (in current US$) of Somalia in 1981 to that in 1983?
Give a very brief answer. 1.17. What is the ratio of the Amount (in current US$) of Uganda in 1981 to that in 1983?
Your response must be concise. 30.4. What is the ratio of the Amount (in current US$) of Jamaica in 1981 to that in 1984?
Provide a short and direct response. 1.08. What is the ratio of the Amount (in current US$) of Mexico in 1981 to that in 1984?
Make the answer very short. 2.63. What is the ratio of the Amount (in current US$) in Somalia in 1981 to that in 1984?
Make the answer very short. 1.39. What is the ratio of the Amount (in current US$) in Uganda in 1981 to that in 1984?
Provide a succinct answer. 4.63. What is the ratio of the Amount (in current US$) in Jamaica in 1981 to that in 1985?
Ensure brevity in your answer.  1.6. What is the ratio of the Amount (in current US$) in Mexico in 1981 to that in 1985?
Your response must be concise. 5.96. What is the ratio of the Amount (in current US$) in Somalia in 1981 to that in 1985?
Offer a very short reply. 3.31. What is the ratio of the Amount (in current US$) of Uganda in 1981 to that in 1985?
Provide a succinct answer. 3.59. What is the ratio of the Amount (in current US$) of Mexico in 1981 to that in 1986?
Make the answer very short. 0.73. What is the ratio of the Amount (in current US$) in Somalia in 1981 to that in 1986?
Offer a terse response. 3.12. What is the ratio of the Amount (in current US$) in Uganda in 1981 to that in 1986?
Provide a short and direct response. 0.72. What is the ratio of the Amount (in current US$) of Jamaica in 1982 to that in 1983?
Provide a short and direct response. 1.14. What is the ratio of the Amount (in current US$) of Mexico in 1982 to that in 1983?
Ensure brevity in your answer.  1.9. What is the ratio of the Amount (in current US$) in Somalia in 1982 to that in 1983?
Your answer should be compact. 0.76. What is the ratio of the Amount (in current US$) in Jamaica in 1982 to that in 1984?
Your answer should be very brief. 1.11. What is the ratio of the Amount (in current US$) in Mexico in 1982 to that in 1984?
Ensure brevity in your answer.  2.97. What is the ratio of the Amount (in current US$) in Somalia in 1982 to that in 1984?
Your answer should be compact. 0.9. What is the ratio of the Amount (in current US$) of Jamaica in 1982 to that in 1985?
Provide a succinct answer. 1.64. What is the ratio of the Amount (in current US$) in Mexico in 1982 to that in 1985?
Offer a terse response. 6.74. What is the ratio of the Amount (in current US$) in Somalia in 1982 to that in 1985?
Keep it short and to the point. 2.15. What is the ratio of the Amount (in current US$) in Mexico in 1982 to that in 1986?
Provide a succinct answer. 0.83. What is the ratio of the Amount (in current US$) of Somalia in 1982 to that in 1986?
Offer a terse response. 2.03. What is the ratio of the Amount (in current US$) in Jamaica in 1983 to that in 1984?
Ensure brevity in your answer.  0.97. What is the ratio of the Amount (in current US$) in Mexico in 1983 to that in 1984?
Give a very brief answer. 1.57. What is the ratio of the Amount (in current US$) in Somalia in 1983 to that in 1984?
Offer a terse response. 1.19. What is the ratio of the Amount (in current US$) in Uganda in 1983 to that in 1984?
Your answer should be compact. 0.15. What is the ratio of the Amount (in current US$) in Jamaica in 1983 to that in 1985?
Provide a short and direct response. 1.44. What is the ratio of the Amount (in current US$) of Mexico in 1983 to that in 1985?
Your answer should be compact. 3.55. What is the ratio of the Amount (in current US$) of Somalia in 1983 to that in 1985?
Your answer should be compact. 2.84. What is the ratio of the Amount (in current US$) of Uganda in 1983 to that in 1985?
Provide a short and direct response. 0.12. What is the ratio of the Amount (in current US$) of Mexico in 1983 to that in 1986?
Provide a succinct answer. 0.44. What is the ratio of the Amount (in current US$) of Somalia in 1983 to that in 1986?
Make the answer very short. 2.67. What is the ratio of the Amount (in current US$) of Uganda in 1983 to that in 1986?
Make the answer very short. 0.02. What is the ratio of the Amount (in current US$) in Jamaica in 1984 to that in 1985?
Give a very brief answer. 1.48. What is the ratio of the Amount (in current US$) in Mexico in 1984 to that in 1985?
Your response must be concise. 2.26. What is the ratio of the Amount (in current US$) of Somalia in 1984 to that in 1985?
Offer a very short reply. 2.39. What is the ratio of the Amount (in current US$) in Uganda in 1984 to that in 1985?
Ensure brevity in your answer.  0.78. What is the ratio of the Amount (in current US$) in Mexico in 1984 to that in 1986?
Offer a very short reply. 0.28. What is the ratio of the Amount (in current US$) of Somalia in 1984 to that in 1986?
Give a very brief answer. 2.25. What is the ratio of the Amount (in current US$) of Uganda in 1984 to that in 1986?
Offer a terse response. 0.16. What is the ratio of the Amount (in current US$) of Mexico in 1985 to that in 1986?
Offer a very short reply. 0.12. What is the ratio of the Amount (in current US$) in Somalia in 1985 to that in 1986?
Offer a very short reply. 0.94. What is the ratio of the Amount (in current US$) in Uganda in 1985 to that in 1986?
Your response must be concise. 0.2. What is the difference between the highest and the second highest Amount (in current US$) of Jamaica?
Offer a terse response. 5.60e+06. What is the difference between the highest and the second highest Amount (in current US$) of Mexico?
Your answer should be compact. 9.36e+07. What is the difference between the highest and the second highest Amount (in current US$) in Somalia?
Make the answer very short. 2.00e+07. What is the difference between the highest and the second highest Amount (in current US$) in Uganda?
Your answer should be compact. 1.15e+07. What is the difference between the highest and the lowest Amount (in current US$) of Jamaica?
Your answer should be very brief. 2.54e+08. What is the difference between the highest and the lowest Amount (in current US$) of Mexico?
Make the answer very short. 4.76e+08. What is the difference between the highest and the lowest Amount (in current US$) of Somalia?
Make the answer very short. 9.72e+07. What is the difference between the highest and the lowest Amount (in current US$) in Uganda?
Make the answer very short. 4.15e+07. 